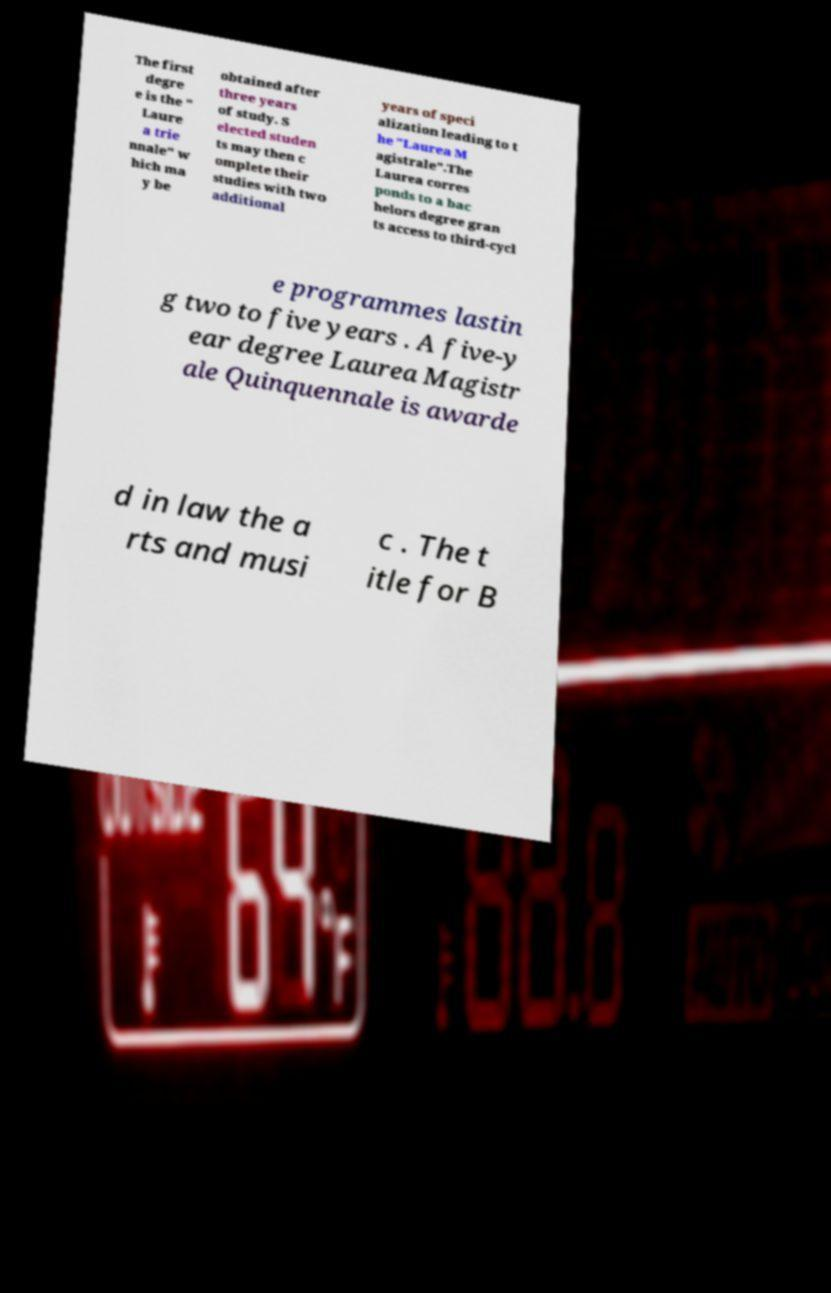Please identify and transcribe the text found in this image. The first degre e is the " Laure a trie nnale" w hich ma y be obtained after three years of study. S elected studen ts may then c omplete their studies with two additional years of speci alization leading to t he "Laurea M agistrale".The Laurea corres ponds to a bac helors degree gran ts access to third-cycl e programmes lastin g two to five years . A five-y ear degree Laurea Magistr ale Quinquennale is awarde d in law the a rts and musi c . The t itle for B 